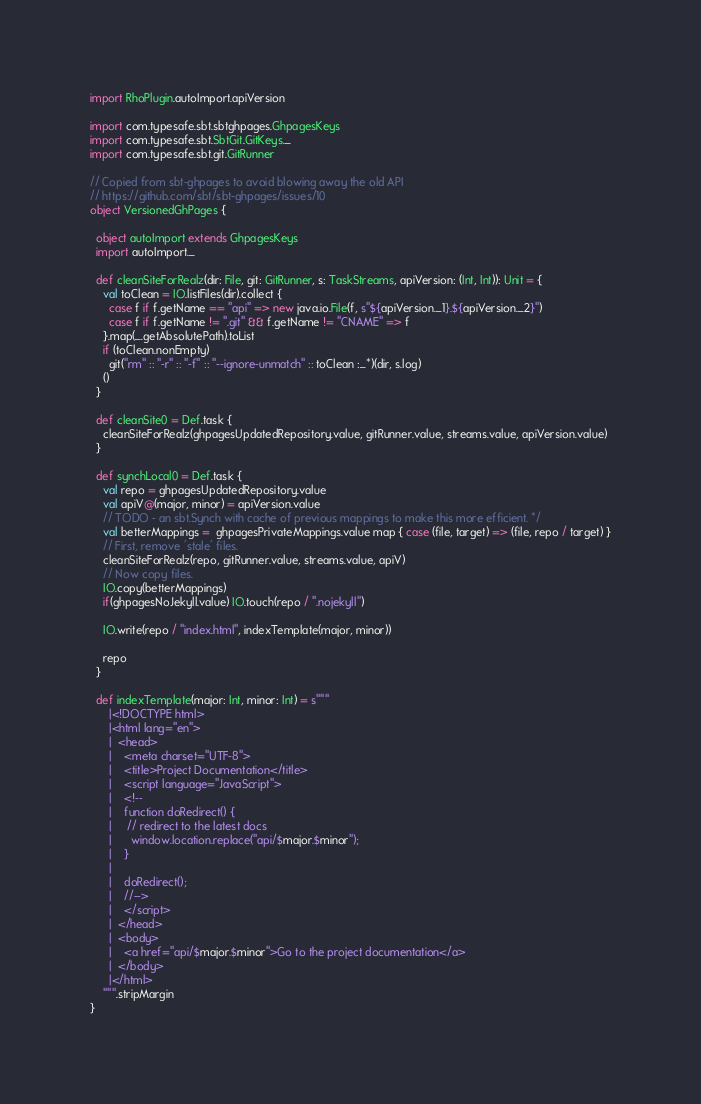Convert code to text. <code><loc_0><loc_0><loc_500><loc_500><_Scala_>
import RhoPlugin.autoImport.apiVersion

import com.typesafe.sbt.sbtghpages.GhpagesKeys
import com.typesafe.sbt.SbtGit.GitKeys._
import com.typesafe.sbt.git.GitRunner

// Copied from sbt-ghpages to avoid blowing away the old API
// https://github.com/sbt/sbt-ghpages/issues/10
object VersionedGhPages {

  object autoImport extends GhpagesKeys
  import autoImport._

  def cleanSiteForRealz(dir: File, git: GitRunner, s: TaskStreams, apiVersion: (Int, Int)): Unit = {
    val toClean = IO.listFiles(dir).collect {
      case f if f.getName == "api" => new java.io.File(f, s"${apiVersion._1}.${apiVersion._2}")
      case f if f.getName != ".git" && f.getName != "CNAME" => f
    }.map(_.getAbsolutePath).toList
    if (toClean.nonEmpty)
      git("rm" :: "-r" :: "-f" :: "--ignore-unmatch" :: toClean :_*)(dir, s.log)
    ()
  }

  def cleanSite0 = Def.task {
    cleanSiteForRealz(ghpagesUpdatedRepository.value, gitRunner.value, streams.value, apiVersion.value)
  }

  def synchLocal0 = Def.task {
    val repo = ghpagesUpdatedRepository.value
    val apiV@(major, minor) = apiVersion.value
    // TODO - an sbt.Synch with cache of previous mappings to make this more efficient. */
    val betterMappings =  ghpagesPrivateMappings.value map { case (file, target) => (file, repo / target) }
    // First, remove 'stale' files.
    cleanSiteForRealz(repo, gitRunner.value, streams.value, apiV)
    // Now copy files.
    IO.copy(betterMappings)
    if(ghpagesNoJekyll.value) IO.touch(repo / ".nojekyll")

    IO.write(repo / "index.html", indexTemplate(major, minor))

    repo
  }

  def indexTemplate(major: Int, minor: Int) = s"""
      |<!DOCTYPE html>
      |<html lang="en">
      |  <head>
      |    <meta charset="UTF-8">
      |    <title>Project Documentation</title>
      |    <script language="JavaScript">
      |    <!--
      |    function doRedirect() {
      |     // redirect to the latest docs
      |      window.location.replace("api/$major.$minor");
      |    }
      |
      |    doRedirect();
      |    //-->
      |    </script>
      |  </head>
      |  <body>
      |    <a href="api/$major.$minor">Go to the project documentation</a>
      |  </body>
      |</html>
    """.stripMargin
}
</code> 